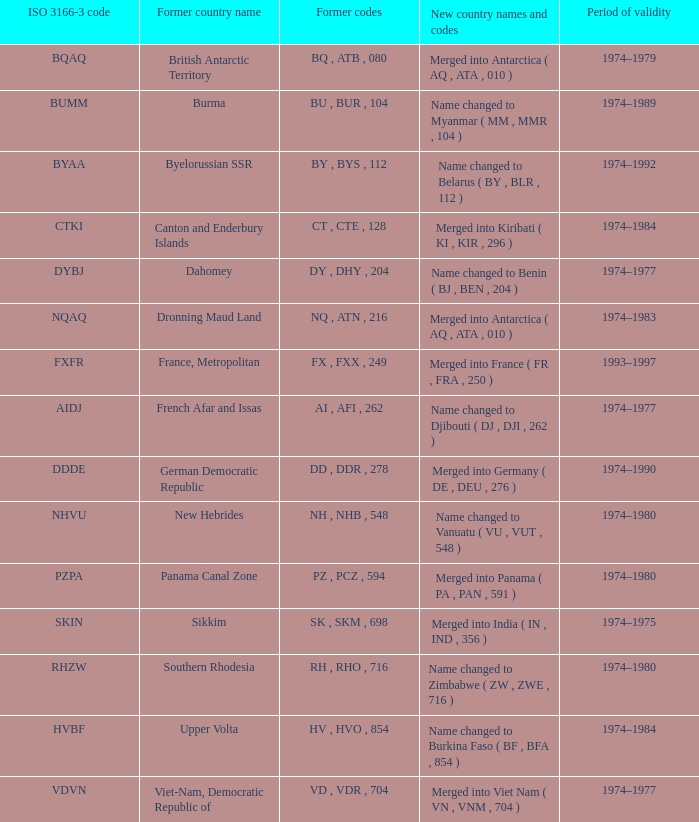Name the total number for period of validity for upper volta 1.0. 